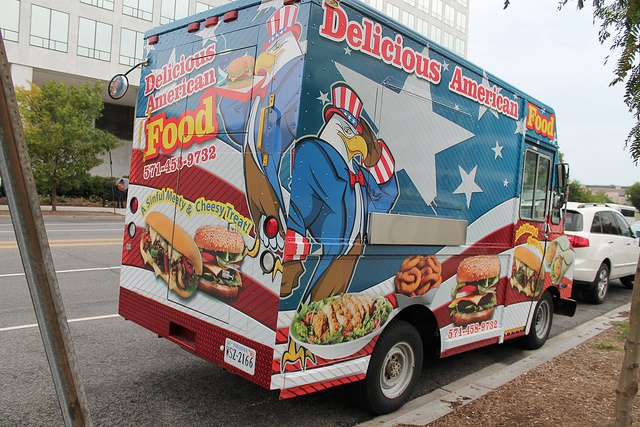Describe the objects in this image and their specific colors. I can see truck in lightgray, darkgray, black, and maroon tones, car in lightgray, black, darkgray, and gray tones, bowl in lightgray, darkgray, and gray tones, car in lightgray, black, darkgray, and gray tones, and car in lightgray, teal, and darkgray tones in this image. 